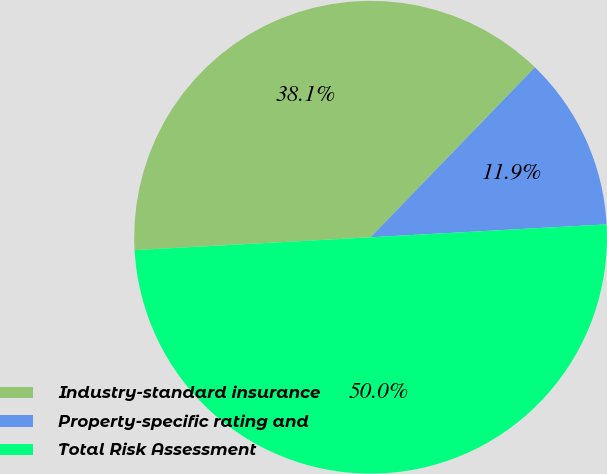Convert chart to OTSL. <chart><loc_0><loc_0><loc_500><loc_500><pie_chart><fcel>Industry-standard insurance<fcel>Property-specific rating and<fcel>Total Risk Assessment<nl><fcel>38.1%<fcel>11.9%<fcel>50.0%<nl></chart> 